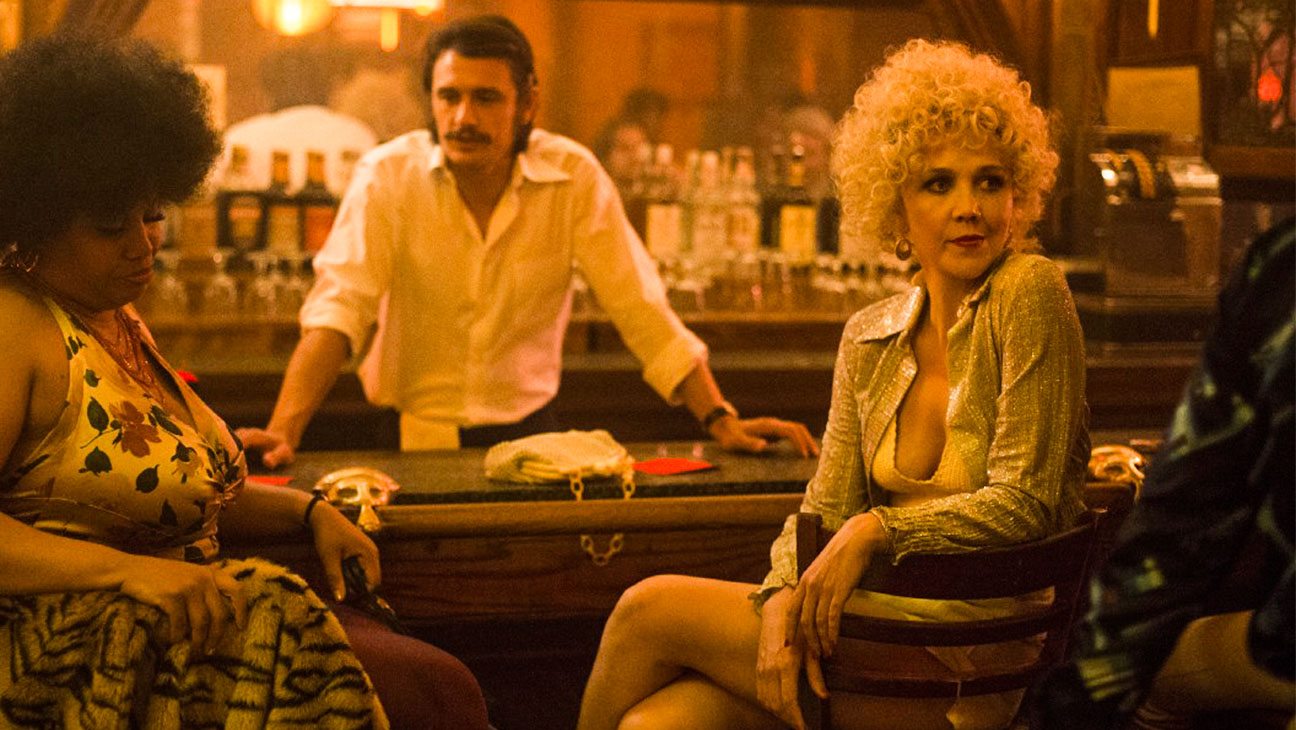Can you elaborate on the emotions being depicted by the people in this image? Certainly. The central woman's expression and poised posture suggest a mixture of confidence and contemplation, possibly hinting at a deeper, personal story. The woman with the afro appears relaxed and content, enjoying the ambiance of the bar. In contrast, the man with a mustache looks somewhat reserved, hinting at attentiveness to the ongoing conversation. The bartender's focus indicates a professional detachment yet an awareness of the bar's dynamics. Each character's expression adds layers to the mood of the scene, signaling a web of personal stories and interactions. 